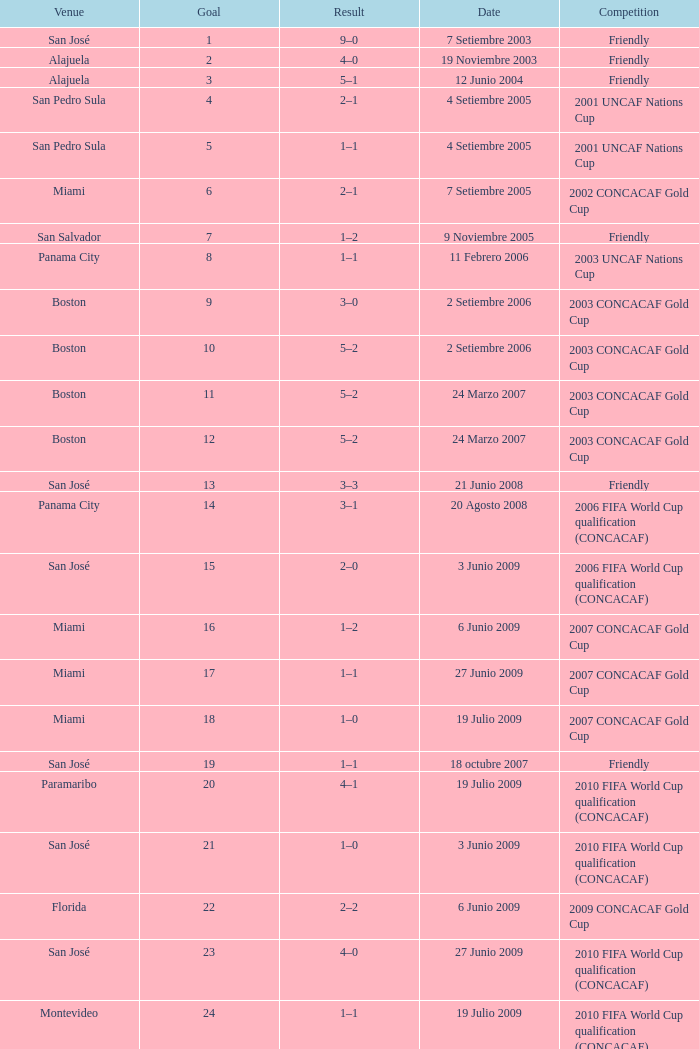How many goals were scored on 21 Junio 2008? 1.0. 